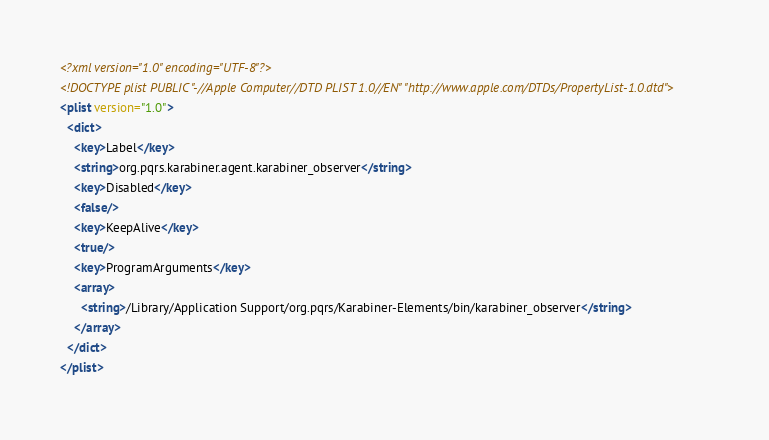Convert code to text. <code><loc_0><loc_0><loc_500><loc_500><_XML_><?xml version="1.0" encoding="UTF-8"?>
<!DOCTYPE plist PUBLIC "-//Apple Computer//DTD PLIST 1.0//EN" "http://www.apple.com/DTDs/PropertyList-1.0.dtd">
<plist version="1.0">
  <dict>
    <key>Label</key>
    <string>org.pqrs.karabiner.agent.karabiner_observer</string>
    <key>Disabled</key>
    <false/>
    <key>KeepAlive</key>
    <true/>
    <key>ProgramArguments</key>
    <array>
      <string>/Library/Application Support/org.pqrs/Karabiner-Elements/bin/karabiner_observer</string>
    </array>
  </dict>
</plist>
</code> 